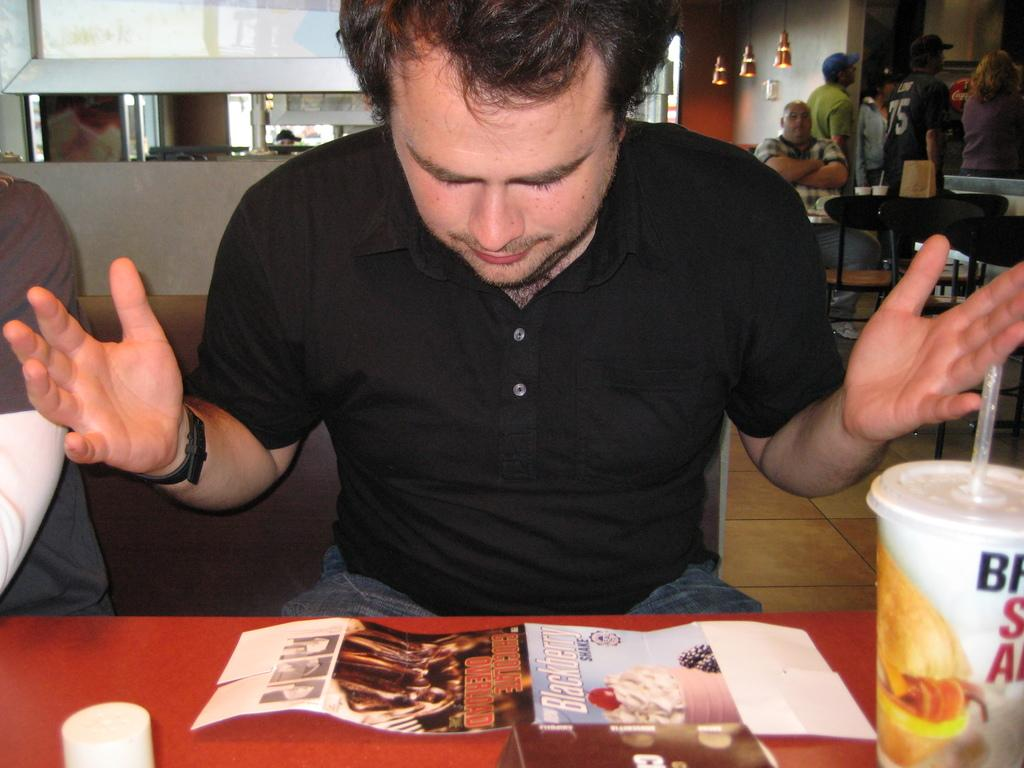How many people are in the image? There is a group of people in the image, but the exact number cannot be determined from the provided facts. What is the primary object in the image? There is a table in the image. What is in the glass with a straw? The facts do not specify what is in the glass with a straw. What is depicted on the poster? The facts do not mention the content of the poster. How many chairs are in the image? There are chairs in the image, but the exact number cannot be determined from the provided facts. What type of lighting is present in the image? There are lights in the image. What is the background of the image? The facts mention a wall in the image, but they do not specify the background. Can you see any animals from the zoo in the image? There is no mention of a zoo or any animals in the image. --- Facts: 1. There is a group of people in the image. 2. There is a table in the image. 3. There is a glass with a straw in the image. 4. There is a poster in the image. 5. There are chairs in the image. 6. There are lights in the image. 7. There is a wall in the image. 8. There are some objects in the image. Absurd Topics: zoo, bun, birth Conversation: How many people are in the image? There is a group of people in the image, but the exact number cannot be determined from the provided facts. What is the primary object in the image? There is a table in the image. What is in the glass with a straw? The facts do not specify what is in the glass. What is depicted on the poster? The facts do not mention the content of the poster. How many chairs are in the image? There are chairs in the image, but the exact number cannot be determined from the provided facts. What type of lighting is present in the image? There are lights in the image. What is the background of the image? The facts mention a wall in the image, but they do not specify the background. Reasoning: Let's think step by step in order to produce the conversation. We start by identifying the main subjects and objects in the image based on the provided facts. We then formulate questions that focus on the location and characteristics of these subjects and objects, ensuring that each question can be answered definitively with the information given. We avoid yes/no questions and ensure that the language is simple and clear. Absurd Question/Answer: Can you see any animals from the zoo in the image? There is no mention of a zoo or any animals in the image. 